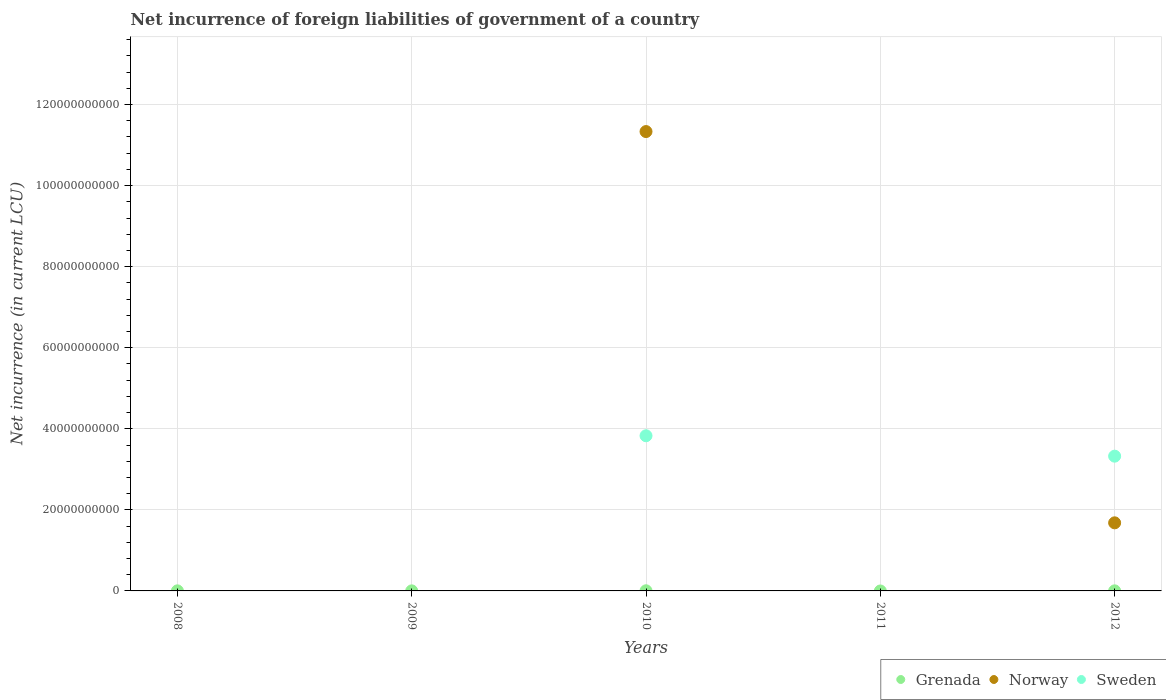How many different coloured dotlines are there?
Offer a terse response. 3. Is the number of dotlines equal to the number of legend labels?
Ensure brevity in your answer.  No. Across all years, what is the maximum net incurrence of foreign liabilities in Grenada?
Your response must be concise. 3.46e+07. Across all years, what is the minimum net incurrence of foreign liabilities in Grenada?
Provide a short and direct response. 0. In which year was the net incurrence of foreign liabilities in Norway maximum?
Provide a short and direct response. 2010. What is the total net incurrence of foreign liabilities in Sweden in the graph?
Your answer should be compact. 7.15e+1. What is the difference between the net incurrence of foreign liabilities in Grenada in 2009 and that in 2012?
Your answer should be very brief. -4.30e+06. What is the difference between the net incurrence of foreign liabilities in Sweden in 2011 and the net incurrence of foreign liabilities in Grenada in 2009?
Offer a very short reply. -1.24e+07. What is the average net incurrence of foreign liabilities in Norway per year?
Ensure brevity in your answer.  2.60e+1. In the year 2010, what is the difference between the net incurrence of foreign liabilities in Norway and net incurrence of foreign liabilities in Sweden?
Your response must be concise. 7.51e+1. In how many years, is the net incurrence of foreign liabilities in Norway greater than 44000000000 LCU?
Provide a succinct answer. 1. What is the ratio of the net incurrence of foreign liabilities in Norway in 2010 to that in 2012?
Your answer should be compact. 6.75. What is the difference between the highest and the second highest net incurrence of foreign liabilities in Grenada?
Offer a terse response. 1.73e+07. What is the difference between the highest and the lowest net incurrence of foreign liabilities in Sweden?
Provide a succinct answer. 3.83e+1. Is the sum of the net incurrence of foreign liabilities in Sweden in 2010 and 2012 greater than the maximum net incurrence of foreign liabilities in Grenada across all years?
Make the answer very short. Yes. How many years are there in the graph?
Make the answer very short. 5. What is the difference between two consecutive major ticks on the Y-axis?
Provide a succinct answer. 2.00e+1. How many legend labels are there?
Your answer should be very brief. 3. What is the title of the graph?
Offer a very short reply. Net incurrence of foreign liabilities of government of a country. Does "East Asia (developing only)" appear as one of the legend labels in the graph?
Provide a succinct answer. No. What is the label or title of the X-axis?
Offer a very short reply. Years. What is the label or title of the Y-axis?
Ensure brevity in your answer.  Net incurrence (in current LCU). What is the Net incurrence (in current LCU) in Grenada in 2008?
Offer a very short reply. 1.73e+07. What is the Net incurrence (in current LCU) in Grenada in 2009?
Offer a terse response. 1.24e+07. What is the Net incurrence (in current LCU) of Norway in 2009?
Offer a terse response. 0. What is the Net incurrence (in current LCU) of Grenada in 2010?
Offer a terse response. 3.46e+07. What is the Net incurrence (in current LCU) of Norway in 2010?
Ensure brevity in your answer.  1.13e+11. What is the Net incurrence (in current LCU) in Sweden in 2010?
Your response must be concise. 3.83e+1. What is the Net incurrence (in current LCU) of Grenada in 2012?
Your answer should be compact. 1.67e+07. What is the Net incurrence (in current LCU) in Norway in 2012?
Offer a terse response. 1.68e+1. What is the Net incurrence (in current LCU) of Sweden in 2012?
Ensure brevity in your answer.  3.32e+1. Across all years, what is the maximum Net incurrence (in current LCU) of Grenada?
Your answer should be very brief. 3.46e+07. Across all years, what is the maximum Net incurrence (in current LCU) in Norway?
Your answer should be compact. 1.13e+11. Across all years, what is the maximum Net incurrence (in current LCU) of Sweden?
Provide a short and direct response. 3.83e+1. Across all years, what is the minimum Net incurrence (in current LCU) in Norway?
Keep it short and to the point. 0. What is the total Net incurrence (in current LCU) of Grenada in the graph?
Your response must be concise. 8.10e+07. What is the total Net incurrence (in current LCU) of Norway in the graph?
Give a very brief answer. 1.30e+11. What is the total Net incurrence (in current LCU) in Sweden in the graph?
Provide a short and direct response. 7.15e+1. What is the difference between the Net incurrence (in current LCU) in Grenada in 2008 and that in 2009?
Your answer should be very brief. 4.90e+06. What is the difference between the Net incurrence (in current LCU) of Grenada in 2008 and that in 2010?
Your answer should be very brief. -1.73e+07. What is the difference between the Net incurrence (in current LCU) of Grenada in 2008 and that in 2012?
Your answer should be very brief. 6.00e+05. What is the difference between the Net incurrence (in current LCU) of Grenada in 2009 and that in 2010?
Your answer should be compact. -2.22e+07. What is the difference between the Net incurrence (in current LCU) in Grenada in 2009 and that in 2012?
Give a very brief answer. -4.30e+06. What is the difference between the Net incurrence (in current LCU) in Grenada in 2010 and that in 2012?
Your answer should be compact. 1.79e+07. What is the difference between the Net incurrence (in current LCU) of Norway in 2010 and that in 2012?
Your answer should be very brief. 9.65e+1. What is the difference between the Net incurrence (in current LCU) of Sweden in 2010 and that in 2012?
Keep it short and to the point. 5.04e+09. What is the difference between the Net incurrence (in current LCU) of Grenada in 2008 and the Net incurrence (in current LCU) of Norway in 2010?
Your answer should be very brief. -1.13e+11. What is the difference between the Net incurrence (in current LCU) in Grenada in 2008 and the Net incurrence (in current LCU) in Sweden in 2010?
Your response must be concise. -3.83e+1. What is the difference between the Net incurrence (in current LCU) of Grenada in 2008 and the Net incurrence (in current LCU) of Norway in 2012?
Ensure brevity in your answer.  -1.68e+1. What is the difference between the Net incurrence (in current LCU) in Grenada in 2008 and the Net incurrence (in current LCU) in Sweden in 2012?
Keep it short and to the point. -3.32e+1. What is the difference between the Net incurrence (in current LCU) of Grenada in 2009 and the Net incurrence (in current LCU) of Norway in 2010?
Keep it short and to the point. -1.13e+11. What is the difference between the Net incurrence (in current LCU) of Grenada in 2009 and the Net incurrence (in current LCU) of Sweden in 2010?
Offer a very short reply. -3.83e+1. What is the difference between the Net incurrence (in current LCU) of Grenada in 2009 and the Net incurrence (in current LCU) of Norway in 2012?
Your answer should be very brief. -1.68e+1. What is the difference between the Net incurrence (in current LCU) of Grenada in 2009 and the Net incurrence (in current LCU) of Sweden in 2012?
Your answer should be very brief. -3.32e+1. What is the difference between the Net incurrence (in current LCU) of Grenada in 2010 and the Net incurrence (in current LCU) of Norway in 2012?
Provide a short and direct response. -1.68e+1. What is the difference between the Net incurrence (in current LCU) in Grenada in 2010 and the Net incurrence (in current LCU) in Sweden in 2012?
Your answer should be compact. -3.32e+1. What is the difference between the Net incurrence (in current LCU) in Norway in 2010 and the Net incurrence (in current LCU) in Sweden in 2012?
Provide a short and direct response. 8.01e+1. What is the average Net incurrence (in current LCU) in Grenada per year?
Provide a succinct answer. 1.62e+07. What is the average Net incurrence (in current LCU) of Norway per year?
Provide a short and direct response. 2.60e+1. What is the average Net incurrence (in current LCU) in Sweden per year?
Give a very brief answer. 1.43e+1. In the year 2010, what is the difference between the Net incurrence (in current LCU) in Grenada and Net incurrence (in current LCU) in Norway?
Your response must be concise. -1.13e+11. In the year 2010, what is the difference between the Net incurrence (in current LCU) in Grenada and Net incurrence (in current LCU) in Sweden?
Give a very brief answer. -3.83e+1. In the year 2010, what is the difference between the Net incurrence (in current LCU) of Norway and Net incurrence (in current LCU) of Sweden?
Give a very brief answer. 7.51e+1. In the year 2012, what is the difference between the Net incurrence (in current LCU) of Grenada and Net incurrence (in current LCU) of Norway?
Give a very brief answer. -1.68e+1. In the year 2012, what is the difference between the Net incurrence (in current LCU) of Grenada and Net incurrence (in current LCU) of Sweden?
Your response must be concise. -3.32e+1. In the year 2012, what is the difference between the Net incurrence (in current LCU) of Norway and Net incurrence (in current LCU) of Sweden?
Make the answer very short. -1.64e+1. What is the ratio of the Net incurrence (in current LCU) of Grenada in 2008 to that in 2009?
Your response must be concise. 1.4. What is the ratio of the Net incurrence (in current LCU) of Grenada in 2008 to that in 2012?
Make the answer very short. 1.04. What is the ratio of the Net incurrence (in current LCU) of Grenada in 2009 to that in 2010?
Offer a terse response. 0.36. What is the ratio of the Net incurrence (in current LCU) of Grenada in 2009 to that in 2012?
Your response must be concise. 0.74. What is the ratio of the Net incurrence (in current LCU) of Grenada in 2010 to that in 2012?
Offer a very short reply. 2.07. What is the ratio of the Net incurrence (in current LCU) in Norway in 2010 to that in 2012?
Your answer should be very brief. 6.75. What is the ratio of the Net incurrence (in current LCU) in Sweden in 2010 to that in 2012?
Provide a short and direct response. 1.15. What is the difference between the highest and the second highest Net incurrence (in current LCU) in Grenada?
Give a very brief answer. 1.73e+07. What is the difference between the highest and the lowest Net incurrence (in current LCU) in Grenada?
Your answer should be very brief. 3.46e+07. What is the difference between the highest and the lowest Net incurrence (in current LCU) in Norway?
Give a very brief answer. 1.13e+11. What is the difference between the highest and the lowest Net incurrence (in current LCU) of Sweden?
Offer a very short reply. 3.83e+1. 